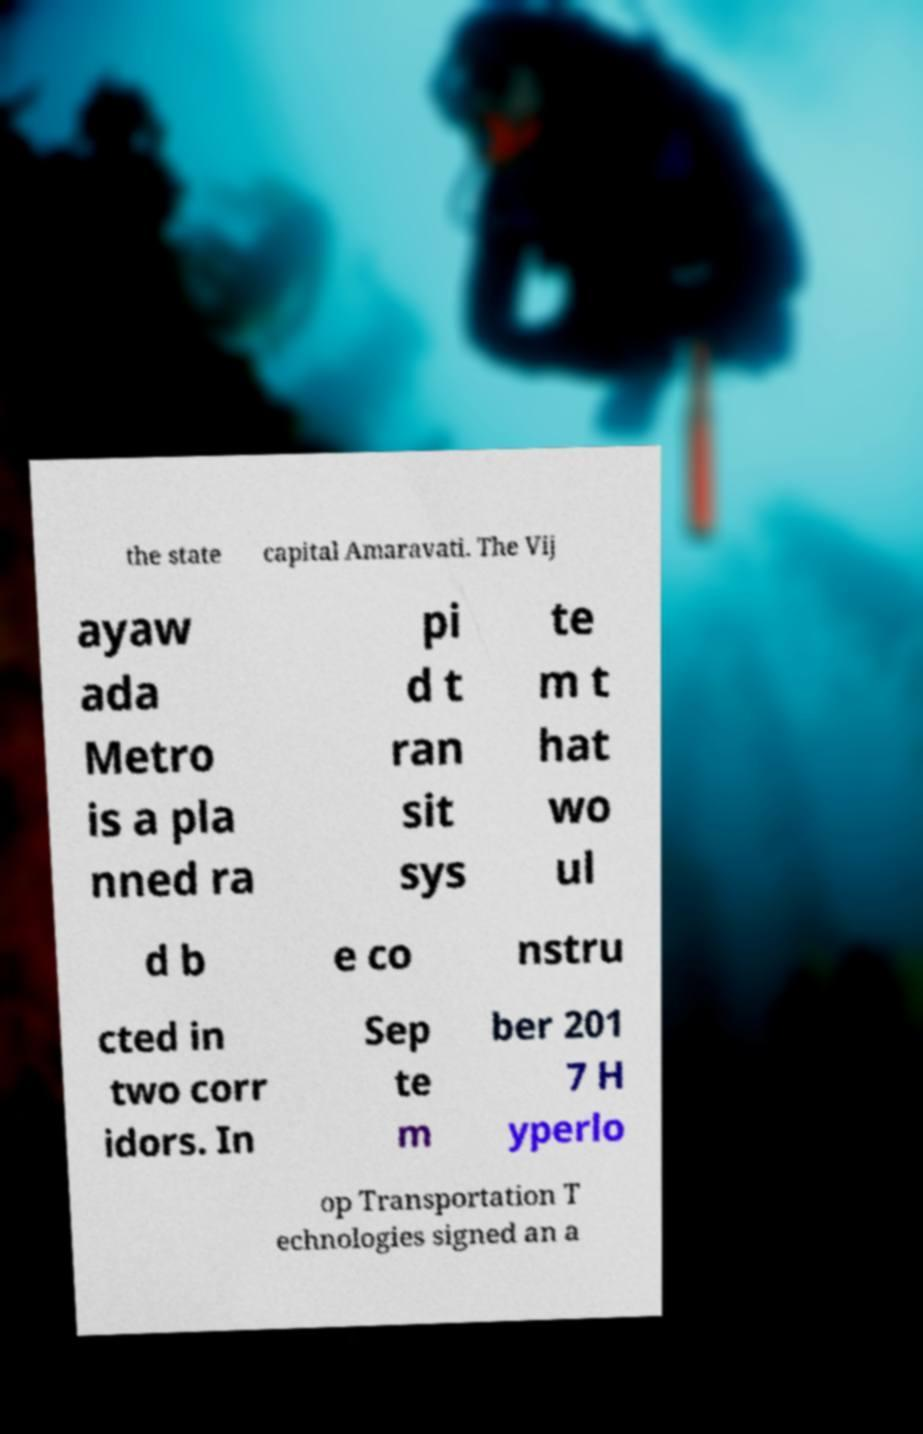Can you read and provide the text displayed in the image?This photo seems to have some interesting text. Can you extract and type it out for me? the state capital Amaravati. The Vij ayaw ada Metro is a pla nned ra pi d t ran sit sys te m t hat wo ul d b e co nstru cted in two corr idors. In Sep te m ber 201 7 H yperlo op Transportation T echnologies signed an a 